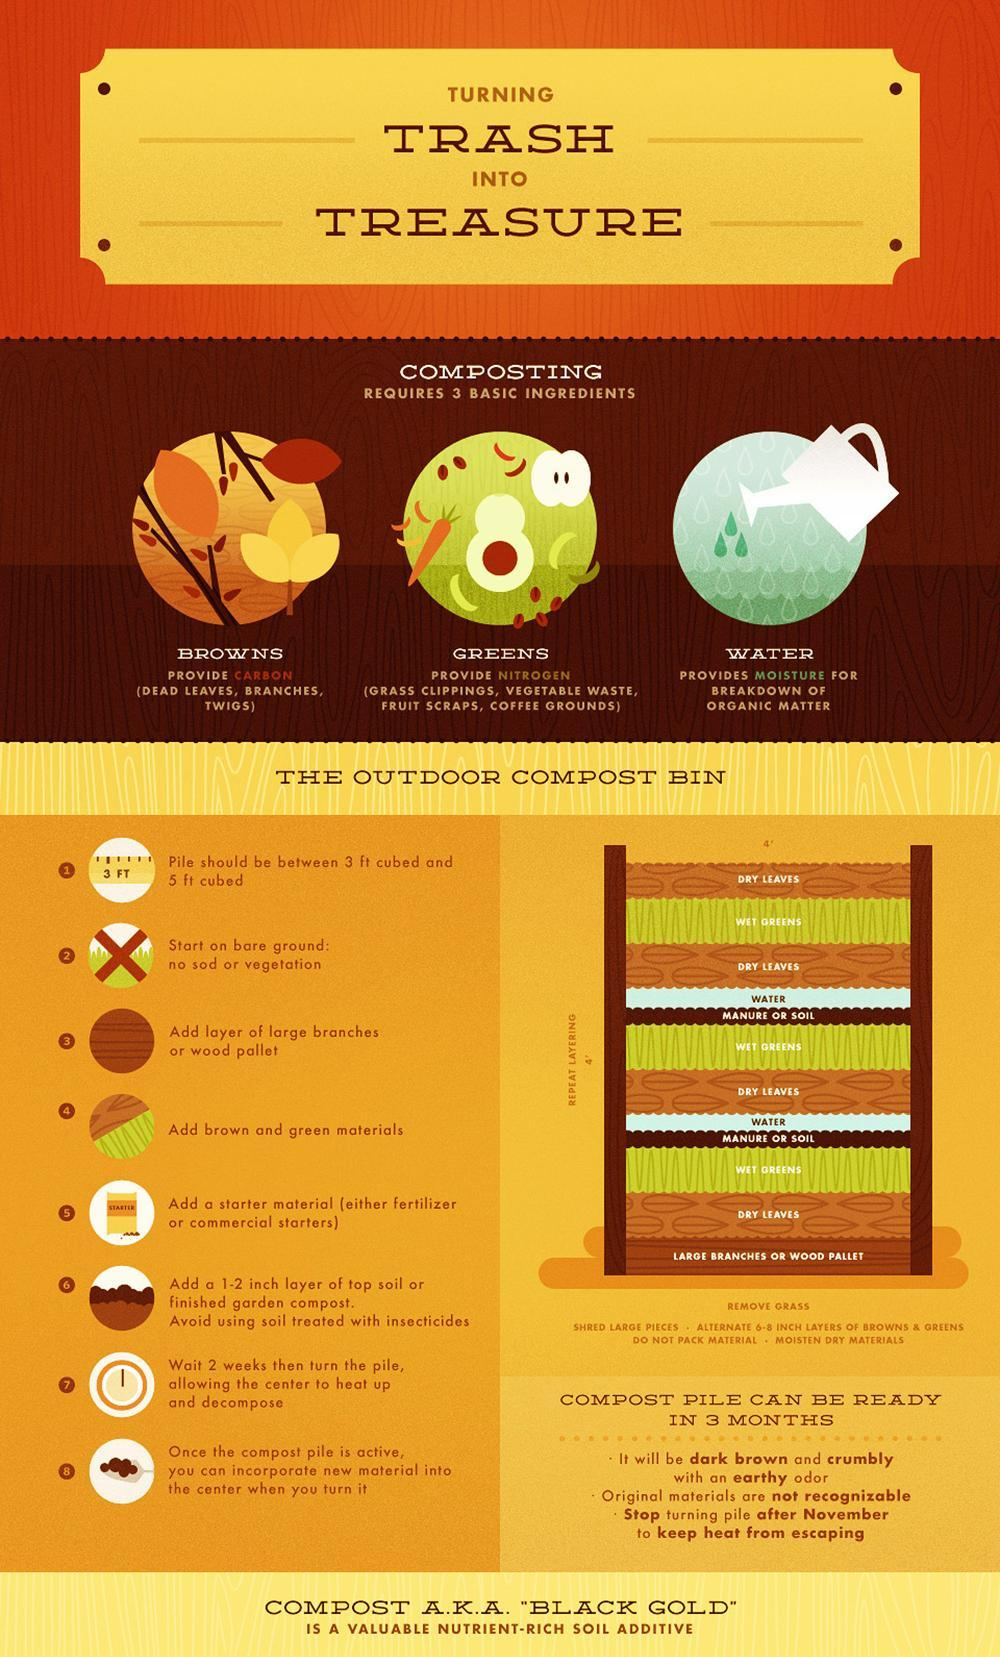What is the peculiarity of Greens?
Answer the question with a short phrase. Provide Nitrogen What is the purpose of water while preparing compost? provides moisture for breakdown of organic matter Which layer of the compost is shown in green color? Wet greens How compost smells? earthy odor What is the peculiarity of Browns? Provide Carbon What are the basic ingredients of compost? Browns, Greens, Water What is the color of compost? dark brown What are the examples of Browns? Dead leaves, branches, twigs :List 3 examples of Greens? Grass Clippings, Vegetable Waste, Fruit scraps 